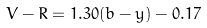<formula> <loc_0><loc_0><loc_500><loc_500>V - R = 1 . 3 0 ( b - y ) - 0 . 1 7</formula> 